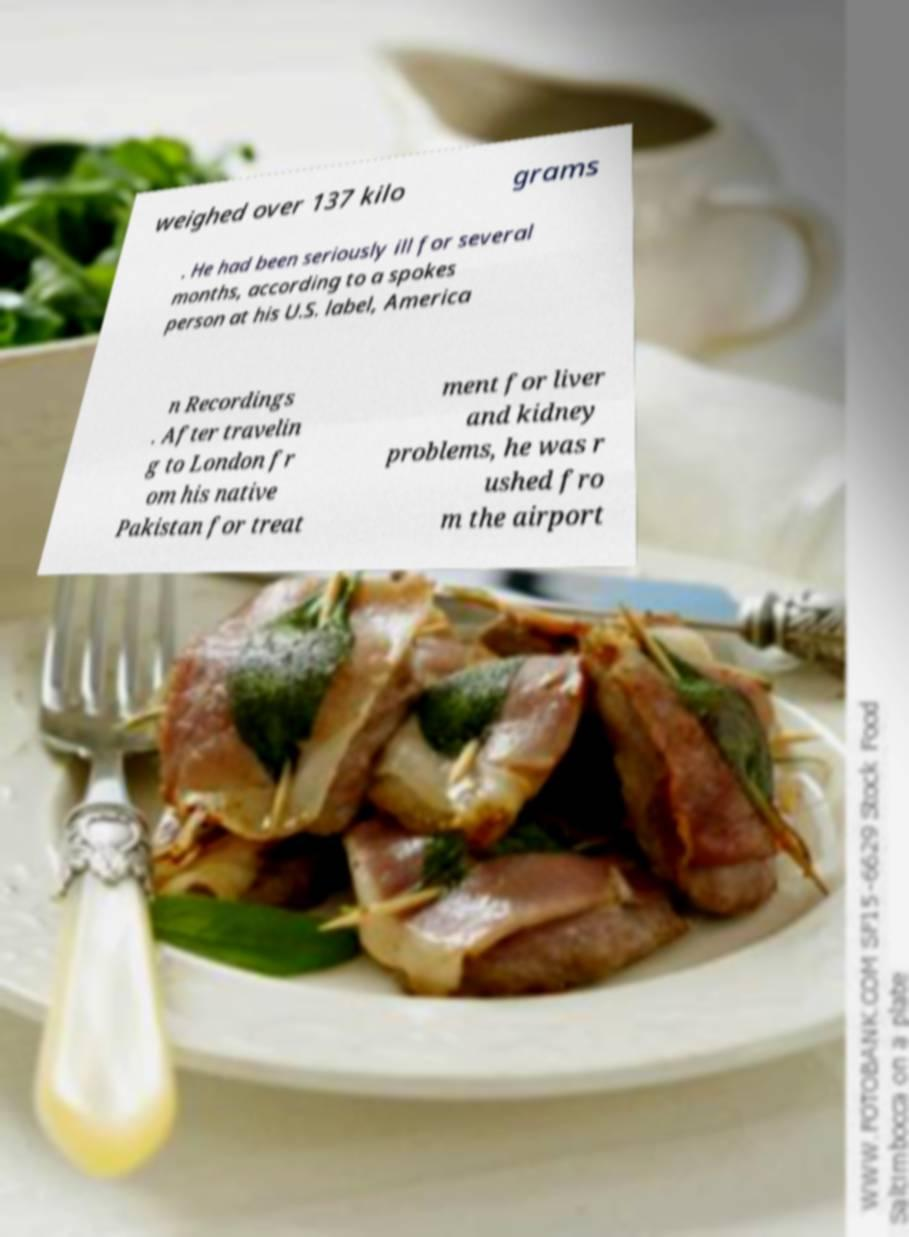For documentation purposes, I need the text within this image transcribed. Could you provide that? weighed over 137 kilo grams . He had been seriously ill for several months, according to a spokes person at his U.S. label, America n Recordings . After travelin g to London fr om his native Pakistan for treat ment for liver and kidney problems, he was r ushed fro m the airport 